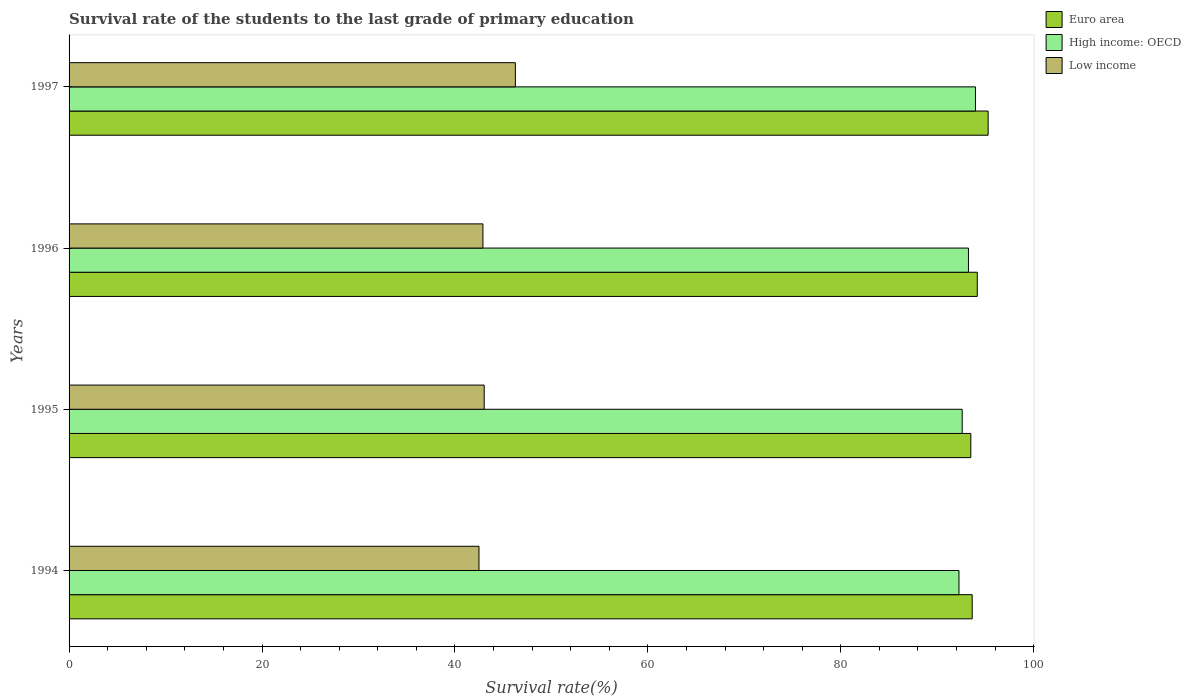How many different coloured bars are there?
Give a very brief answer. 3. How many bars are there on the 1st tick from the top?
Keep it short and to the point. 3. How many bars are there on the 1st tick from the bottom?
Ensure brevity in your answer.  3. What is the label of the 4th group of bars from the top?
Offer a very short reply. 1994. What is the survival rate of the students in High income: OECD in 1996?
Your response must be concise. 93.23. Across all years, what is the maximum survival rate of the students in High income: OECD?
Ensure brevity in your answer.  93.96. Across all years, what is the minimum survival rate of the students in Euro area?
Offer a terse response. 93.48. In which year was the survival rate of the students in Low income maximum?
Provide a succinct answer. 1997. In which year was the survival rate of the students in Euro area minimum?
Provide a short and direct response. 1995. What is the total survival rate of the students in Euro area in the graph?
Keep it short and to the point. 376.52. What is the difference between the survival rate of the students in Euro area in 1995 and that in 1996?
Your answer should be very brief. -0.67. What is the difference between the survival rate of the students in High income: OECD in 1995 and the survival rate of the students in Euro area in 1997?
Keep it short and to the point. -2.69. What is the average survival rate of the students in Euro area per year?
Give a very brief answer. 94.13. In the year 1994, what is the difference between the survival rate of the students in High income: OECD and survival rate of the students in Euro area?
Offer a terse response. -1.37. What is the ratio of the survival rate of the students in Euro area in 1994 to that in 1997?
Your response must be concise. 0.98. Is the difference between the survival rate of the students in High income: OECD in 1994 and 1995 greater than the difference between the survival rate of the students in Euro area in 1994 and 1995?
Your response must be concise. No. What is the difference between the highest and the second highest survival rate of the students in Euro area?
Your response must be concise. 1.13. What is the difference between the highest and the lowest survival rate of the students in Low income?
Give a very brief answer. 3.77. In how many years, is the survival rate of the students in Low income greater than the average survival rate of the students in Low income taken over all years?
Offer a terse response. 1. What does the 2nd bar from the top in 1996 represents?
Make the answer very short. High income: OECD. What does the 3rd bar from the bottom in 1997 represents?
Your response must be concise. Low income. Is it the case that in every year, the sum of the survival rate of the students in Low income and survival rate of the students in High income: OECD is greater than the survival rate of the students in Euro area?
Keep it short and to the point. Yes. How many bars are there?
Keep it short and to the point. 12. What is the difference between two consecutive major ticks on the X-axis?
Your response must be concise. 20. Does the graph contain any zero values?
Offer a terse response. No. How many legend labels are there?
Provide a succinct answer. 3. What is the title of the graph?
Your answer should be very brief. Survival rate of the students to the last grade of primary education. Does "Middle East & North Africa (developing only)" appear as one of the legend labels in the graph?
Your response must be concise. No. What is the label or title of the X-axis?
Make the answer very short. Survival rate(%). What is the label or title of the Y-axis?
Your answer should be compact. Years. What is the Survival rate(%) of Euro area in 1994?
Keep it short and to the point. 93.62. What is the Survival rate(%) in High income: OECD in 1994?
Your answer should be very brief. 92.25. What is the Survival rate(%) in Low income in 1994?
Your response must be concise. 42.49. What is the Survival rate(%) of Euro area in 1995?
Offer a terse response. 93.48. What is the Survival rate(%) of High income: OECD in 1995?
Keep it short and to the point. 92.58. What is the Survival rate(%) in Low income in 1995?
Make the answer very short. 43.03. What is the Survival rate(%) of Euro area in 1996?
Your response must be concise. 94.15. What is the Survival rate(%) in High income: OECD in 1996?
Provide a succinct answer. 93.23. What is the Survival rate(%) of Low income in 1996?
Keep it short and to the point. 42.9. What is the Survival rate(%) in Euro area in 1997?
Your response must be concise. 95.27. What is the Survival rate(%) in High income: OECD in 1997?
Your answer should be very brief. 93.96. What is the Survival rate(%) of Low income in 1997?
Your answer should be very brief. 46.27. Across all years, what is the maximum Survival rate(%) of Euro area?
Offer a very short reply. 95.27. Across all years, what is the maximum Survival rate(%) in High income: OECD?
Your answer should be compact. 93.96. Across all years, what is the maximum Survival rate(%) of Low income?
Your response must be concise. 46.27. Across all years, what is the minimum Survival rate(%) in Euro area?
Provide a short and direct response. 93.48. Across all years, what is the minimum Survival rate(%) in High income: OECD?
Offer a very short reply. 92.25. Across all years, what is the minimum Survival rate(%) of Low income?
Your answer should be compact. 42.49. What is the total Survival rate(%) in Euro area in the graph?
Your answer should be very brief. 376.52. What is the total Survival rate(%) of High income: OECD in the graph?
Provide a short and direct response. 372.03. What is the total Survival rate(%) in Low income in the graph?
Ensure brevity in your answer.  174.69. What is the difference between the Survival rate(%) in Euro area in 1994 and that in 1995?
Your response must be concise. 0.14. What is the difference between the Survival rate(%) of High income: OECD in 1994 and that in 1995?
Your answer should be compact. -0.34. What is the difference between the Survival rate(%) of Low income in 1994 and that in 1995?
Your response must be concise. -0.54. What is the difference between the Survival rate(%) of Euro area in 1994 and that in 1996?
Provide a short and direct response. -0.53. What is the difference between the Survival rate(%) in High income: OECD in 1994 and that in 1996?
Give a very brief answer. -0.98. What is the difference between the Survival rate(%) of Low income in 1994 and that in 1996?
Give a very brief answer. -0.41. What is the difference between the Survival rate(%) of Euro area in 1994 and that in 1997?
Your answer should be very brief. -1.65. What is the difference between the Survival rate(%) of High income: OECD in 1994 and that in 1997?
Your answer should be compact. -1.71. What is the difference between the Survival rate(%) in Low income in 1994 and that in 1997?
Your answer should be very brief. -3.77. What is the difference between the Survival rate(%) of Euro area in 1995 and that in 1996?
Make the answer very short. -0.67. What is the difference between the Survival rate(%) of High income: OECD in 1995 and that in 1996?
Offer a terse response. -0.65. What is the difference between the Survival rate(%) in Low income in 1995 and that in 1996?
Provide a short and direct response. 0.13. What is the difference between the Survival rate(%) of Euro area in 1995 and that in 1997?
Your answer should be very brief. -1.8. What is the difference between the Survival rate(%) of High income: OECD in 1995 and that in 1997?
Offer a very short reply. -1.37. What is the difference between the Survival rate(%) of Low income in 1995 and that in 1997?
Offer a terse response. -3.23. What is the difference between the Survival rate(%) in Euro area in 1996 and that in 1997?
Make the answer very short. -1.13. What is the difference between the Survival rate(%) of High income: OECD in 1996 and that in 1997?
Your response must be concise. -0.73. What is the difference between the Survival rate(%) in Low income in 1996 and that in 1997?
Make the answer very short. -3.36. What is the difference between the Survival rate(%) of Euro area in 1994 and the Survival rate(%) of High income: OECD in 1995?
Make the answer very short. 1.04. What is the difference between the Survival rate(%) in Euro area in 1994 and the Survival rate(%) in Low income in 1995?
Your answer should be very brief. 50.59. What is the difference between the Survival rate(%) in High income: OECD in 1994 and the Survival rate(%) in Low income in 1995?
Offer a very short reply. 49.21. What is the difference between the Survival rate(%) in Euro area in 1994 and the Survival rate(%) in High income: OECD in 1996?
Make the answer very short. 0.39. What is the difference between the Survival rate(%) in Euro area in 1994 and the Survival rate(%) in Low income in 1996?
Give a very brief answer. 50.72. What is the difference between the Survival rate(%) in High income: OECD in 1994 and the Survival rate(%) in Low income in 1996?
Offer a very short reply. 49.35. What is the difference between the Survival rate(%) in Euro area in 1994 and the Survival rate(%) in High income: OECD in 1997?
Give a very brief answer. -0.34. What is the difference between the Survival rate(%) in Euro area in 1994 and the Survival rate(%) in Low income in 1997?
Your response must be concise. 47.35. What is the difference between the Survival rate(%) of High income: OECD in 1994 and the Survival rate(%) of Low income in 1997?
Ensure brevity in your answer.  45.98. What is the difference between the Survival rate(%) of Euro area in 1995 and the Survival rate(%) of High income: OECD in 1996?
Your answer should be very brief. 0.24. What is the difference between the Survival rate(%) in Euro area in 1995 and the Survival rate(%) in Low income in 1996?
Offer a very short reply. 50.57. What is the difference between the Survival rate(%) in High income: OECD in 1995 and the Survival rate(%) in Low income in 1996?
Offer a terse response. 49.68. What is the difference between the Survival rate(%) in Euro area in 1995 and the Survival rate(%) in High income: OECD in 1997?
Make the answer very short. -0.48. What is the difference between the Survival rate(%) of Euro area in 1995 and the Survival rate(%) of Low income in 1997?
Make the answer very short. 47.21. What is the difference between the Survival rate(%) of High income: OECD in 1995 and the Survival rate(%) of Low income in 1997?
Your answer should be very brief. 46.32. What is the difference between the Survival rate(%) of Euro area in 1996 and the Survival rate(%) of High income: OECD in 1997?
Offer a terse response. 0.19. What is the difference between the Survival rate(%) of Euro area in 1996 and the Survival rate(%) of Low income in 1997?
Give a very brief answer. 47.88. What is the difference between the Survival rate(%) of High income: OECD in 1996 and the Survival rate(%) of Low income in 1997?
Your answer should be very brief. 46.97. What is the average Survival rate(%) in Euro area per year?
Keep it short and to the point. 94.13. What is the average Survival rate(%) in High income: OECD per year?
Provide a succinct answer. 93.01. What is the average Survival rate(%) of Low income per year?
Provide a succinct answer. 43.67. In the year 1994, what is the difference between the Survival rate(%) in Euro area and Survival rate(%) in High income: OECD?
Your answer should be compact. 1.37. In the year 1994, what is the difference between the Survival rate(%) in Euro area and Survival rate(%) in Low income?
Keep it short and to the point. 51.13. In the year 1994, what is the difference between the Survival rate(%) in High income: OECD and Survival rate(%) in Low income?
Your response must be concise. 49.76. In the year 1995, what is the difference between the Survival rate(%) in Euro area and Survival rate(%) in High income: OECD?
Your answer should be very brief. 0.89. In the year 1995, what is the difference between the Survival rate(%) in Euro area and Survival rate(%) in Low income?
Give a very brief answer. 50.44. In the year 1995, what is the difference between the Survival rate(%) in High income: OECD and Survival rate(%) in Low income?
Your response must be concise. 49.55. In the year 1996, what is the difference between the Survival rate(%) of Euro area and Survival rate(%) of High income: OECD?
Keep it short and to the point. 0.91. In the year 1996, what is the difference between the Survival rate(%) in Euro area and Survival rate(%) in Low income?
Give a very brief answer. 51.24. In the year 1996, what is the difference between the Survival rate(%) of High income: OECD and Survival rate(%) of Low income?
Your answer should be very brief. 50.33. In the year 1997, what is the difference between the Survival rate(%) in Euro area and Survival rate(%) in High income: OECD?
Provide a succinct answer. 1.31. In the year 1997, what is the difference between the Survival rate(%) of Euro area and Survival rate(%) of Low income?
Offer a terse response. 49.01. In the year 1997, what is the difference between the Survival rate(%) in High income: OECD and Survival rate(%) in Low income?
Offer a very short reply. 47.69. What is the ratio of the Survival rate(%) in Euro area in 1994 to that in 1995?
Give a very brief answer. 1. What is the ratio of the Survival rate(%) of High income: OECD in 1994 to that in 1995?
Make the answer very short. 1. What is the ratio of the Survival rate(%) in Low income in 1994 to that in 1995?
Give a very brief answer. 0.99. What is the ratio of the Survival rate(%) of High income: OECD in 1994 to that in 1996?
Offer a very short reply. 0.99. What is the ratio of the Survival rate(%) of Euro area in 1994 to that in 1997?
Offer a very short reply. 0.98. What is the ratio of the Survival rate(%) of High income: OECD in 1994 to that in 1997?
Make the answer very short. 0.98. What is the ratio of the Survival rate(%) in Low income in 1994 to that in 1997?
Keep it short and to the point. 0.92. What is the ratio of the Survival rate(%) of High income: OECD in 1995 to that in 1996?
Make the answer very short. 0.99. What is the ratio of the Survival rate(%) in Euro area in 1995 to that in 1997?
Offer a terse response. 0.98. What is the ratio of the Survival rate(%) in High income: OECD in 1995 to that in 1997?
Offer a very short reply. 0.99. What is the ratio of the Survival rate(%) of Low income in 1995 to that in 1997?
Keep it short and to the point. 0.93. What is the ratio of the Survival rate(%) in High income: OECD in 1996 to that in 1997?
Ensure brevity in your answer.  0.99. What is the ratio of the Survival rate(%) in Low income in 1996 to that in 1997?
Your answer should be compact. 0.93. What is the difference between the highest and the second highest Survival rate(%) in Euro area?
Your answer should be compact. 1.13. What is the difference between the highest and the second highest Survival rate(%) in High income: OECD?
Your answer should be compact. 0.73. What is the difference between the highest and the second highest Survival rate(%) of Low income?
Provide a short and direct response. 3.23. What is the difference between the highest and the lowest Survival rate(%) of Euro area?
Your answer should be compact. 1.8. What is the difference between the highest and the lowest Survival rate(%) in High income: OECD?
Provide a short and direct response. 1.71. What is the difference between the highest and the lowest Survival rate(%) in Low income?
Your response must be concise. 3.77. 